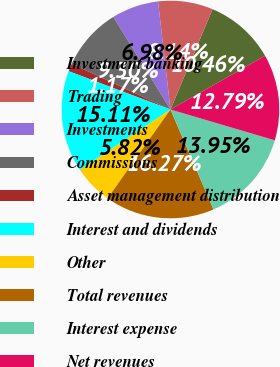<chart> <loc_0><loc_0><loc_500><loc_500><pie_chart><fcel>Investment banking<fcel>Trading<fcel>Investments<fcel>Commissions<fcel>Asset management distribution<fcel>Interest and dividends<fcel>Other<fcel>Total revenues<fcel>Interest expense<fcel>Net revenues<nl><fcel>10.46%<fcel>8.14%<fcel>6.98%<fcel>9.3%<fcel>1.17%<fcel>15.11%<fcel>5.82%<fcel>16.27%<fcel>13.95%<fcel>12.79%<nl></chart> 